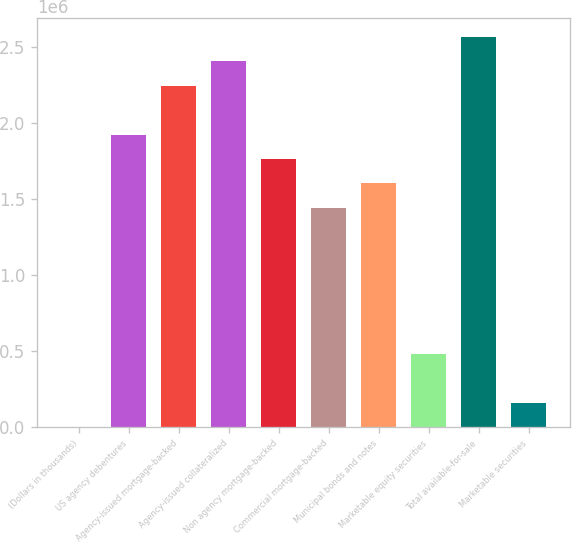<chart> <loc_0><loc_0><loc_500><loc_500><bar_chart><fcel>(Dollars in thousands)<fcel>US agency debentures<fcel>Agency-issued mortgage-backed<fcel>Agency-issued collateralized<fcel>Non agency mortgage-backed<fcel>Commercial mortgage-backed<fcel>Municipal bonds and notes<fcel>Marketable equity securities<fcel>Total available-for-sale<fcel>Marketable securities<nl><fcel>2007<fcel>1.92269e+06<fcel>2.2428e+06<fcel>2.40286e+06<fcel>1.76263e+06<fcel>1.44252e+06<fcel>1.60257e+06<fcel>482177<fcel>2.56291e+06<fcel>162064<nl></chart> 